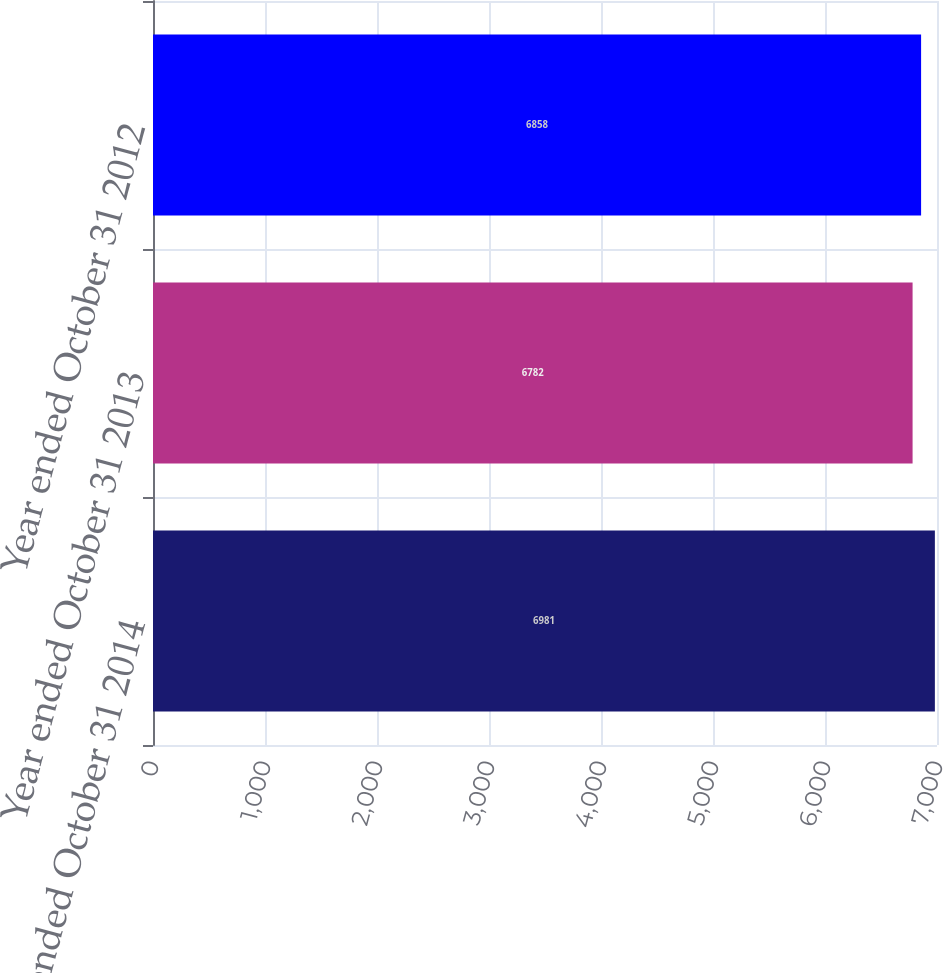Convert chart to OTSL. <chart><loc_0><loc_0><loc_500><loc_500><bar_chart><fcel>Year ended October 31 2014<fcel>Year ended October 31 2013<fcel>Year ended October 31 2012<nl><fcel>6981<fcel>6782<fcel>6858<nl></chart> 